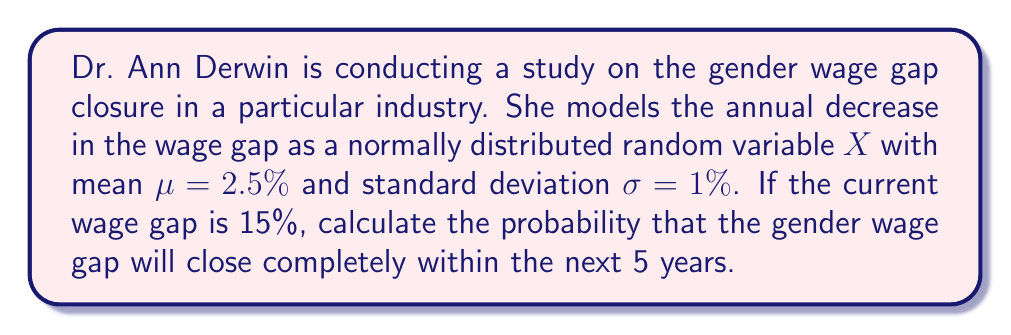Show me your answer to this math problem. Let's approach this step-by-step:

1) First, we need to calculate the total decrease in wage gap needed for complete closure:
   Current gap = 15%
   
2) Now, we need to find the probability that the sum of 5 annual decreases (each represented by $X$) is greater than or equal to 15%.

3) Let $Y = X_1 + X_2 + X_3 + X_4 + X_5$, where each $X_i$ represents the annual decrease for year $i$.

4) Since $X$ is normally distributed, $Y$ is also normally distributed with:
   $\mu_Y = 5 \cdot \mu_X = 5 \cdot 2.5\% = 12.5\%$
   $\sigma_Y = \sqrt{5} \cdot \sigma_X = \sqrt{5} \cdot 1\% = 2.24\%$

5) We want to find $P(Y \geq 15\%)$

6) Standardizing this:
   $Z = \frac{Y - \mu_Y}{\sigma_Y} = \frac{15\% - 12.5\%}{2.24\%} = 1.12$

7) We need to find $P(Z \geq 1.12)$

8) Using a standard normal table or calculator:
   $P(Z \geq 1.12) = 1 - P(Z < 1.12) = 1 - 0.8686 = 0.1314$

Therefore, the probability that the gender wage gap will close completely within the next 5 years is approximately 0.1314 or 13.14%.
Answer: $0.1314$ or $13.14\%$ 